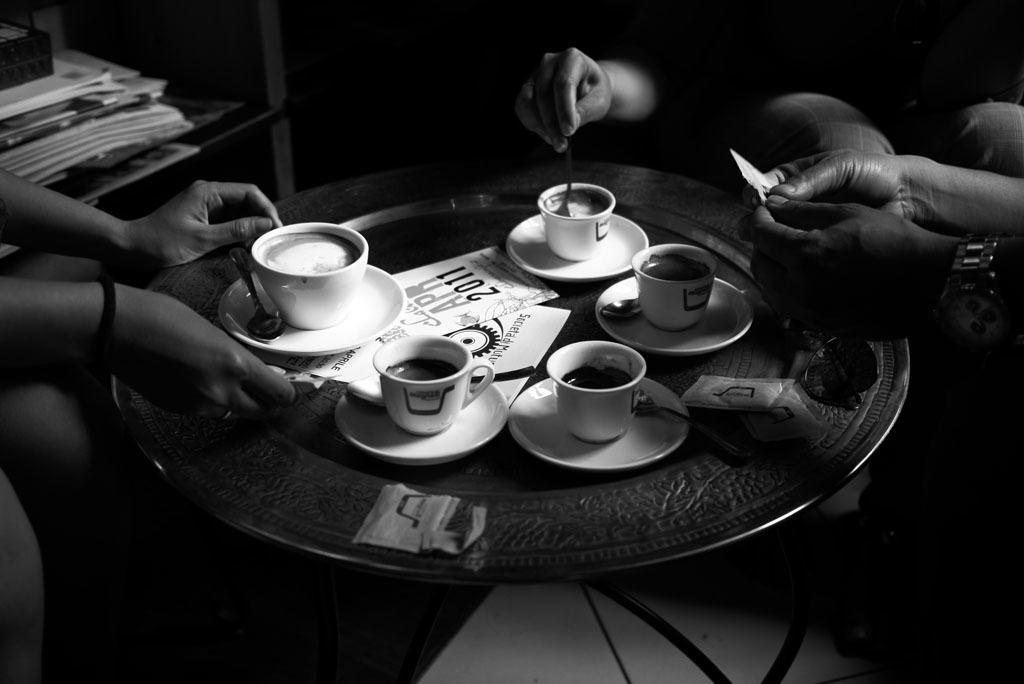In one or two sentences, can you explain what this image depicts? In the middle of the picture, we see a table on which four cups, four saucers and four spoon and papers are placed on it. We see hands of three people around the table and on the left top of the picture, we see many papers placed on table. 